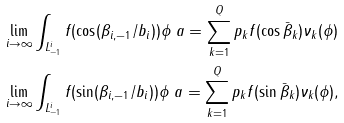<formula> <loc_0><loc_0><loc_500><loc_500>& \lim _ { i \to \infty } \int _ { L ^ { i } _ { - 1 } } f ( \cos ( \beta _ { i , - 1 } / b _ { i } ) ) \phi \ a = \sum _ { k = 1 } ^ { Q } p _ { k } f ( \cos \bar { \beta } _ { k } ) \nu _ { k } ( \phi ) \\ & \lim _ { i \to \infty } \int _ { L ^ { i } _ { - 1 } } f ( \sin ( \beta _ { i , - 1 } / b _ { i } ) ) \phi \ a = \sum _ { k = 1 } ^ { Q } p _ { k } f ( \sin \bar { \beta } _ { k } ) \nu _ { k } ( \phi ) ,</formula> 